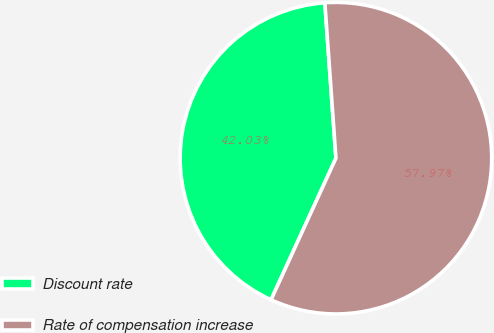<chart> <loc_0><loc_0><loc_500><loc_500><pie_chart><fcel>Discount rate<fcel>Rate of compensation increase<nl><fcel>42.03%<fcel>57.97%<nl></chart> 